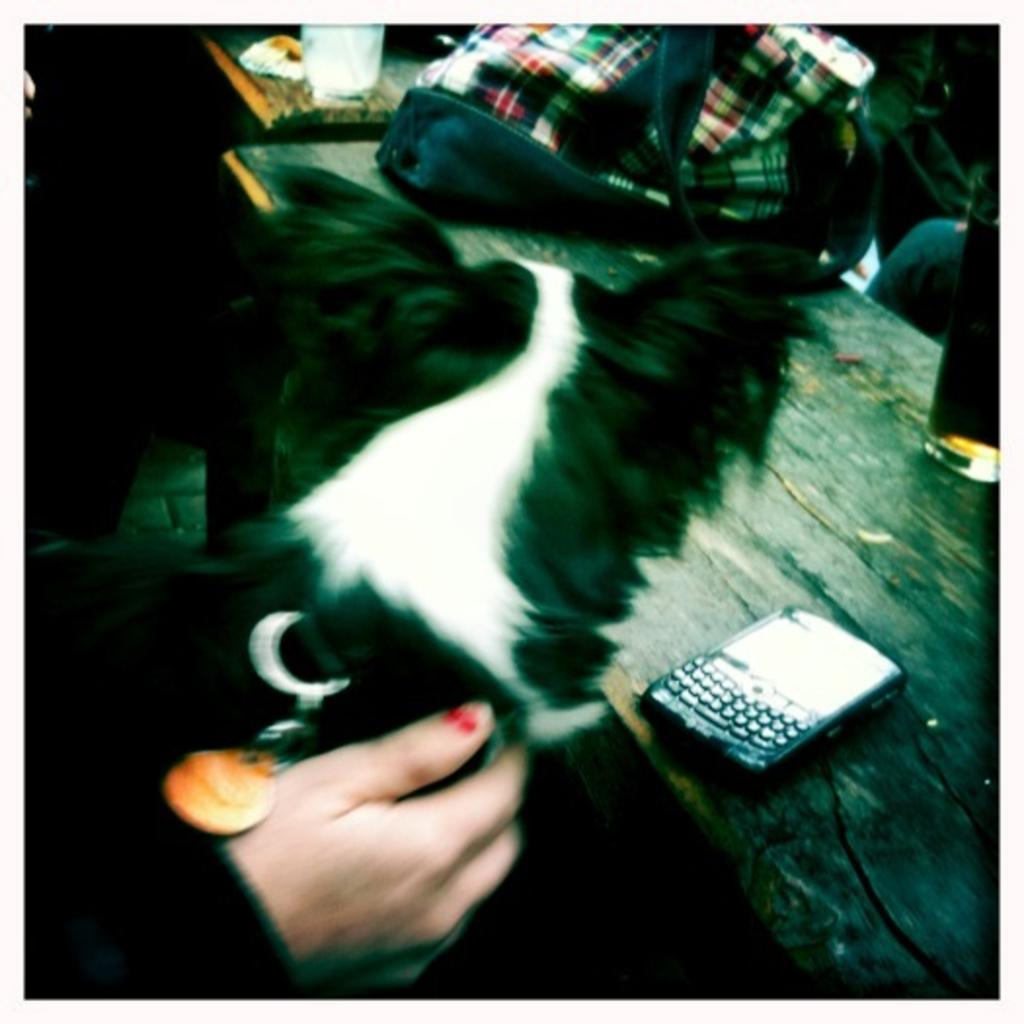What type of animal is in the picture? There is a dog in the picture. How is the dog interacting with a person in the image? A person's hand is placed on the dog. What can be seen in the right corner of the image? There is a table in the right corner of the image. What electronic device is on the table? A mobile phone is present on the table. What other objects are on the table besides the mobile phone? There are other objects on the table. What is the chance of the dog winning a low-stakes poker game in the image? There is no indication of a poker game or any gambling activity in the image, so it is not possible to determine the dog's chances of winning. 